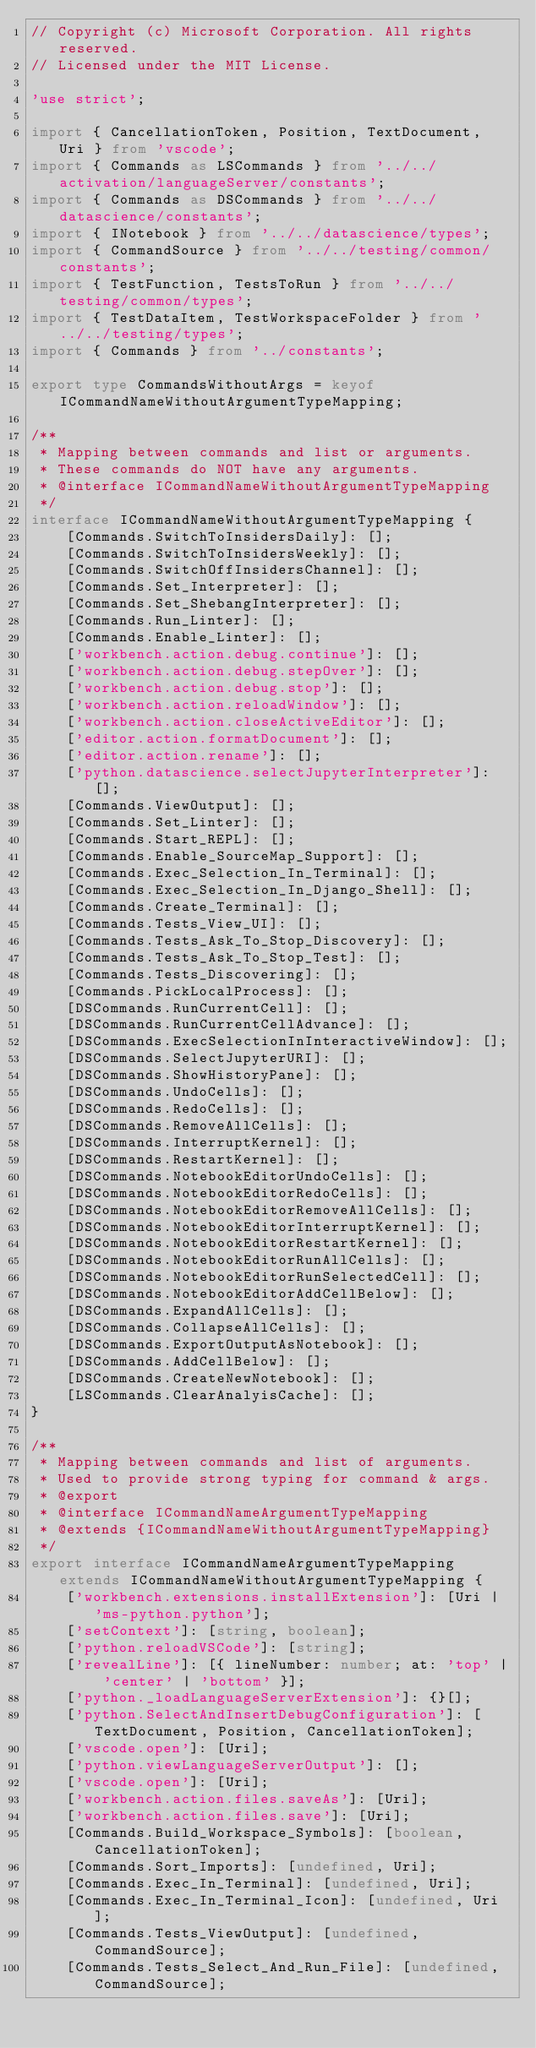<code> <loc_0><loc_0><loc_500><loc_500><_TypeScript_>// Copyright (c) Microsoft Corporation. All rights reserved.
// Licensed under the MIT License.

'use strict';

import { CancellationToken, Position, TextDocument, Uri } from 'vscode';
import { Commands as LSCommands } from '../../activation/languageServer/constants';
import { Commands as DSCommands } from '../../datascience/constants';
import { INotebook } from '../../datascience/types';
import { CommandSource } from '../../testing/common/constants';
import { TestFunction, TestsToRun } from '../../testing/common/types';
import { TestDataItem, TestWorkspaceFolder } from '../../testing/types';
import { Commands } from '../constants';

export type CommandsWithoutArgs = keyof ICommandNameWithoutArgumentTypeMapping;

/**
 * Mapping between commands and list or arguments.
 * These commands do NOT have any arguments.
 * @interface ICommandNameWithoutArgumentTypeMapping
 */
interface ICommandNameWithoutArgumentTypeMapping {
    [Commands.SwitchToInsidersDaily]: [];
    [Commands.SwitchToInsidersWeekly]: [];
    [Commands.SwitchOffInsidersChannel]: [];
    [Commands.Set_Interpreter]: [];
    [Commands.Set_ShebangInterpreter]: [];
    [Commands.Run_Linter]: [];
    [Commands.Enable_Linter]: [];
    ['workbench.action.debug.continue']: [];
    ['workbench.action.debug.stepOver']: [];
    ['workbench.action.debug.stop']: [];
    ['workbench.action.reloadWindow']: [];
    ['workbench.action.closeActiveEditor']: [];
    ['editor.action.formatDocument']: [];
    ['editor.action.rename']: [];
    ['python.datascience.selectJupyterInterpreter']: [];
    [Commands.ViewOutput]: [];
    [Commands.Set_Linter]: [];
    [Commands.Start_REPL]: [];
    [Commands.Enable_SourceMap_Support]: [];
    [Commands.Exec_Selection_In_Terminal]: [];
    [Commands.Exec_Selection_In_Django_Shell]: [];
    [Commands.Create_Terminal]: [];
    [Commands.Tests_View_UI]: [];
    [Commands.Tests_Ask_To_Stop_Discovery]: [];
    [Commands.Tests_Ask_To_Stop_Test]: [];
    [Commands.Tests_Discovering]: [];
    [Commands.PickLocalProcess]: [];
    [DSCommands.RunCurrentCell]: [];
    [DSCommands.RunCurrentCellAdvance]: [];
    [DSCommands.ExecSelectionInInteractiveWindow]: [];
    [DSCommands.SelectJupyterURI]: [];
    [DSCommands.ShowHistoryPane]: [];
    [DSCommands.UndoCells]: [];
    [DSCommands.RedoCells]: [];
    [DSCommands.RemoveAllCells]: [];
    [DSCommands.InterruptKernel]: [];
    [DSCommands.RestartKernel]: [];
    [DSCommands.NotebookEditorUndoCells]: [];
    [DSCommands.NotebookEditorRedoCells]: [];
    [DSCommands.NotebookEditorRemoveAllCells]: [];
    [DSCommands.NotebookEditorInterruptKernel]: [];
    [DSCommands.NotebookEditorRestartKernel]: [];
    [DSCommands.NotebookEditorRunAllCells]: [];
    [DSCommands.NotebookEditorRunSelectedCell]: [];
    [DSCommands.NotebookEditorAddCellBelow]: [];
    [DSCommands.ExpandAllCells]: [];
    [DSCommands.CollapseAllCells]: [];
    [DSCommands.ExportOutputAsNotebook]: [];
    [DSCommands.AddCellBelow]: [];
    [DSCommands.CreateNewNotebook]: [];
    [LSCommands.ClearAnalyisCache]: [];
}

/**
 * Mapping between commands and list of arguments.
 * Used to provide strong typing for command & args.
 * @export
 * @interface ICommandNameArgumentTypeMapping
 * @extends {ICommandNameWithoutArgumentTypeMapping}
 */
export interface ICommandNameArgumentTypeMapping extends ICommandNameWithoutArgumentTypeMapping {
    ['workbench.extensions.installExtension']: [Uri | 'ms-python.python'];
    ['setContext']: [string, boolean];
    ['python.reloadVSCode']: [string];
    ['revealLine']: [{ lineNumber: number; at: 'top' | 'center' | 'bottom' }];
    ['python._loadLanguageServerExtension']: {}[];
    ['python.SelectAndInsertDebugConfiguration']: [TextDocument, Position, CancellationToken];
    ['vscode.open']: [Uri];
    ['python.viewLanguageServerOutput']: [];
    ['vscode.open']: [Uri];
    ['workbench.action.files.saveAs']: [Uri];
    ['workbench.action.files.save']: [Uri];
    [Commands.Build_Workspace_Symbols]: [boolean, CancellationToken];
    [Commands.Sort_Imports]: [undefined, Uri];
    [Commands.Exec_In_Terminal]: [undefined, Uri];
    [Commands.Exec_In_Terminal_Icon]: [undefined, Uri];
    [Commands.Tests_ViewOutput]: [undefined, CommandSource];
    [Commands.Tests_Select_And_Run_File]: [undefined, CommandSource];</code> 